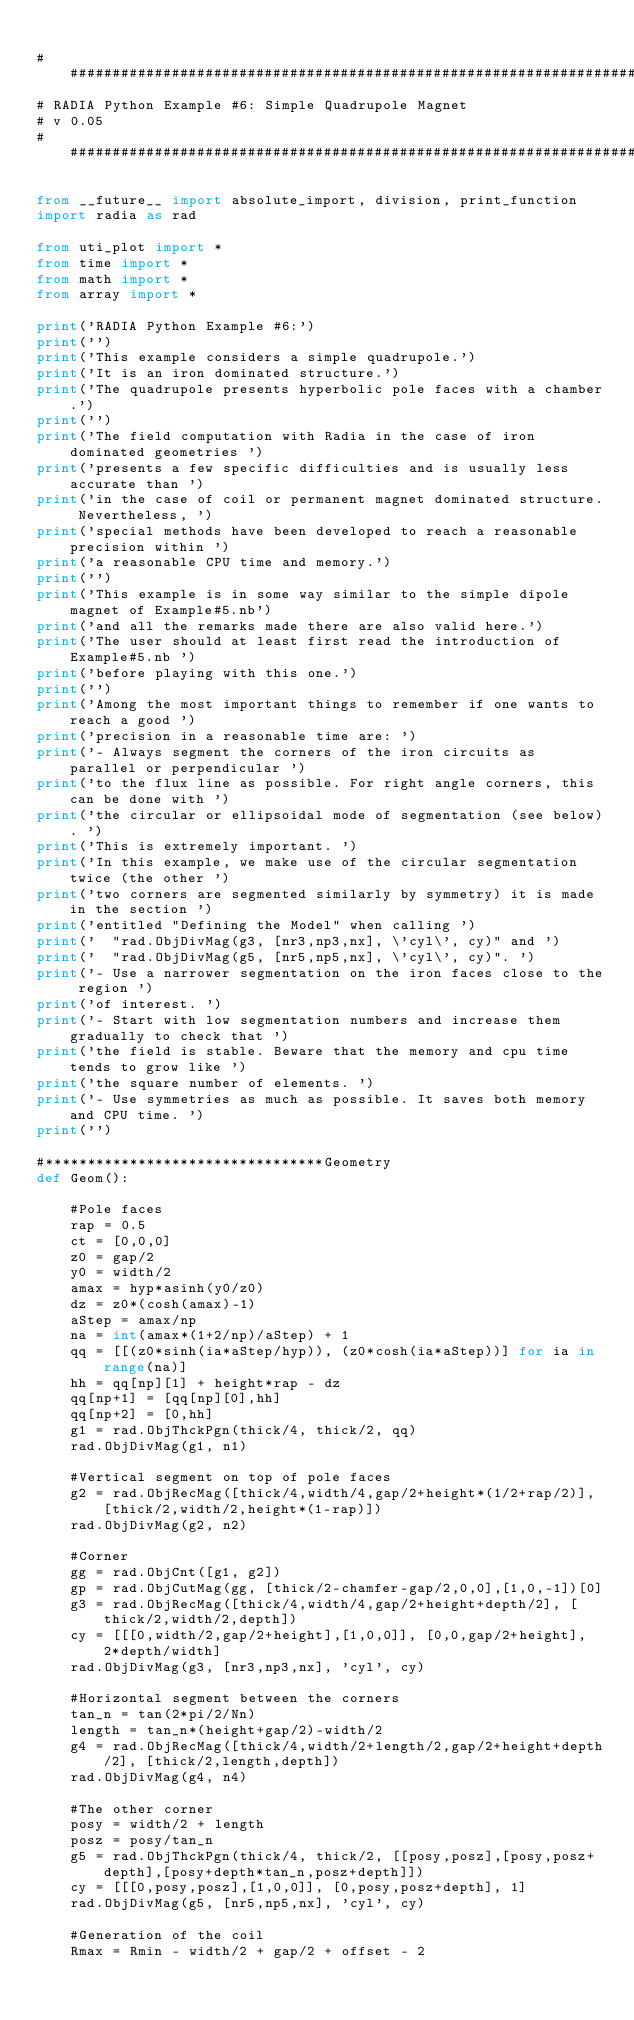<code> <loc_0><loc_0><loc_500><loc_500><_Python_>
#############################################################################
# RADIA Python Example #6: Simple Quadrupole Magnet
# v 0.05
#############################################################################

from __future__ import absolute_import, division, print_function
import radia as rad

from uti_plot import *
from time import *
from math import *
from array import *

print('RADIA Python Example #6:')
print('')
print('This example considers a simple quadrupole.')
print('It is an iron dominated structure.')
print('The quadrupole presents hyperbolic pole faces with a chamber.')
print('')
print('The field computation with Radia in the case of iron dominated geometries ')
print('presents a few specific difficulties and is usually less accurate than ')
print('in the case of coil or permanent magnet dominated structure. Nevertheless, ')
print('special methods have been developed to reach a reasonable precision within ')
print('a reasonable CPU time and memory.')
print('')
print('This example is in some way similar to the simple dipole magnet of Example#5.nb')
print('and all the remarks made there are also valid here.')
print('The user should at least first read the introduction of Example#5.nb ')
print('before playing with this one.')
print('')
print('Among the most important things to remember if one wants to reach a good ')
print('precision in a reasonable time are: ')
print('- Always segment the corners of the iron circuits as parallel or perpendicular ')
print('to the flux line as possible. For right angle corners, this can be done with ')
print('the circular or ellipsoidal mode of segmentation (see below). ')
print('This is extremely important. ')
print('In this example, we make use of the circular segmentation twice (the other ')
print('two corners are segmented similarly by symmetry) it is made in the section ')
print('entitled "Defining the Model" when calling ')
print('  "rad.ObjDivMag(g3, [nr3,np3,nx], \'cyl\', cy)" and ')
print('  "rad.ObjDivMag(g5, [nr5,np5,nx], \'cyl\', cy)". ')
print('- Use a narrower segmentation on the iron faces close to the region ')
print('of interest. ')
print('- Start with low segmentation numbers and increase them gradually to check that ')
print('the field is stable. Beware that the memory and cpu time tends to grow like ')
print('the square number of elements. ')
print('- Use symmetries as much as possible. It saves both memory and CPU time. ')
print('')

#*********************************Geometry
def Geom():

    #Pole faces
    rap = 0.5
    ct = [0,0,0]
    z0 = gap/2
    y0 = width/2
    amax = hyp*asinh(y0/z0)
    dz = z0*(cosh(amax)-1)
    aStep = amax/np
    na = int(amax*(1+2/np)/aStep) + 1
    qq = [[(z0*sinh(ia*aStep/hyp)), (z0*cosh(ia*aStep))] for ia in range(na)]
    hh = qq[np][1] + height*rap - dz
    qq[np+1] = [qq[np][0],hh]
    qq[np+2] = [0,hh]
    g1 = rad.ObjThckPgn(thick/4, thick/2, qq)   
    rad.ObjDivMag(g1, n1)

    #Vertical segment on top of pole faces
    g2 = rad.ObjRecMag([thick/4,width/4,gap/2+height*(1/2+rap/2)], [thick/2,width/2,height*(1-rap)])
    rad.ObjDivMag(g2, n2)

    #Corner
    gg = rad.ObjCnt([g1, g2])
    gp = rad.ObjCutMag(gg, [thick/2-chamfer-gap/2,0,0],[1,0,-1])[0]
    g3 = rad.ObjRecMag([thick/4,width/4,gap/2+height+depth/2], [thick/2,width/2,depth])
    cy = [[[0,width/2,gap/2+height],[1,0,0]], [0,0,gap/2+height], 2*depth/width]
    rad.ObjDivMag(g3, [nr3,np3,nx], 'cyl', cy)

    #Horizontal segment between the corners
    tan_n = tan(2*pi/2/Nn)
    length = tan_n*(height+gap/2)-width/2
    g4 = rad.ObjRecMag([thick/4,width/2+length/2,gap/2+height+depth/2], [thick/2,length,depth])
    rad.ObjDivMag(g4, n4)

    #The other corner
    posy = width/2 + length
    posz = posy/tan_n
    g5 = rad.ObjThckPgn(thick/4, thick/2, [[posy,posz],[posy,posz+depth],[posy+depth*tan_n,posz+depth]])
    cy = [[[0,posy,posz],[1,0,0]], [0,posy,posz+depth], 1]
    rad.ObjDivMag(g5, [nr5,np5,nx], 'cyl', cy)

    #Generation of the coil
    Rmax = Rmin - width/2 + gap/2 + offset - 2</code> 